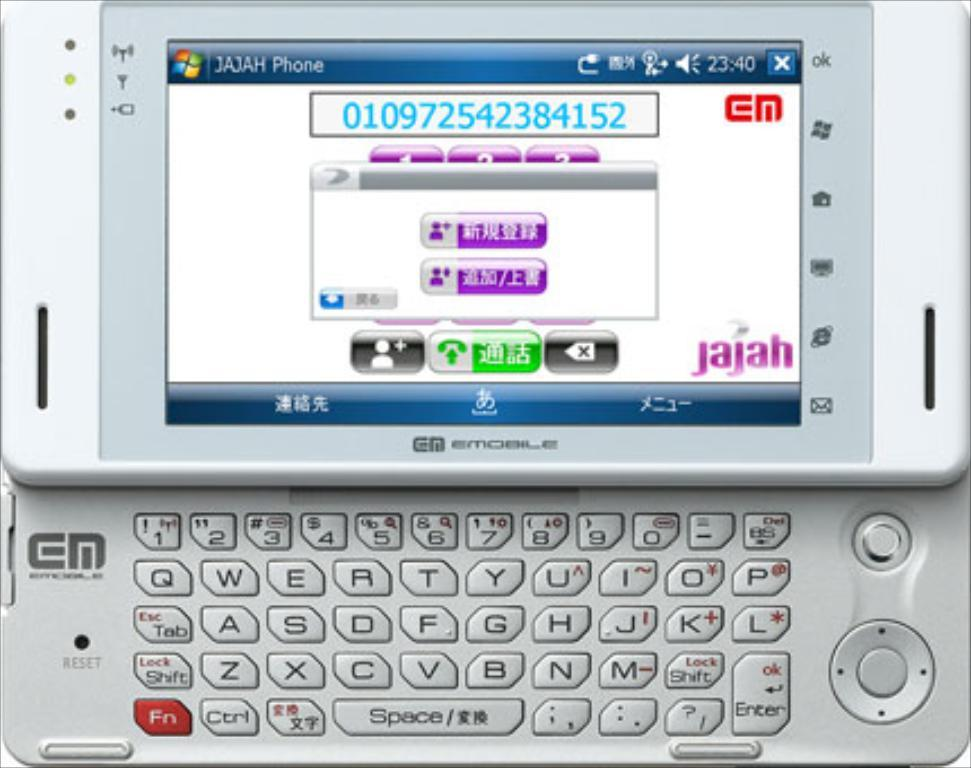<image>
Render a clear and concise summary of the photo. the name Jajah is on the white background of the phone 